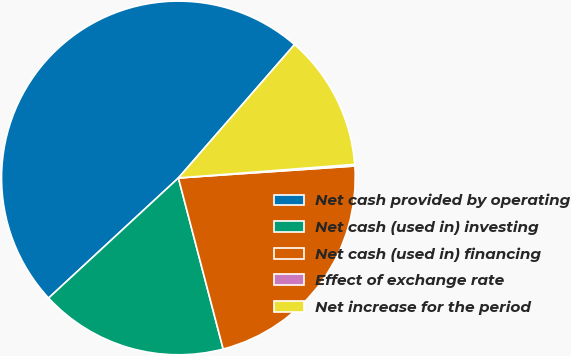Convert chart to OTSL. <chart><loc_0><loc_0><loc_500><loc_500><pie_chart><fcel>Net cash provided by operating<fcel>Net cash (used in) investing<fcel>Net cash (used in) financing<fcel>Effect of exchange rate<fcel>Net increase for the period<nl><fcel>48.28%<fcel>17.19%<fcel>22.0%<fcel>0.15%<fcel>12.37%<nl></chart> 